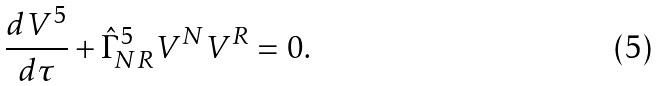Convert formula to latex. <formula><loc_0><loc_0><loc_500><loc_500>\frac { d V ^ { 5 } } { d \tau } + \hat { \Gamma } ^ { 5 } _ { N R } V ^ { N } V ^ { R } = 0 .</formula> 